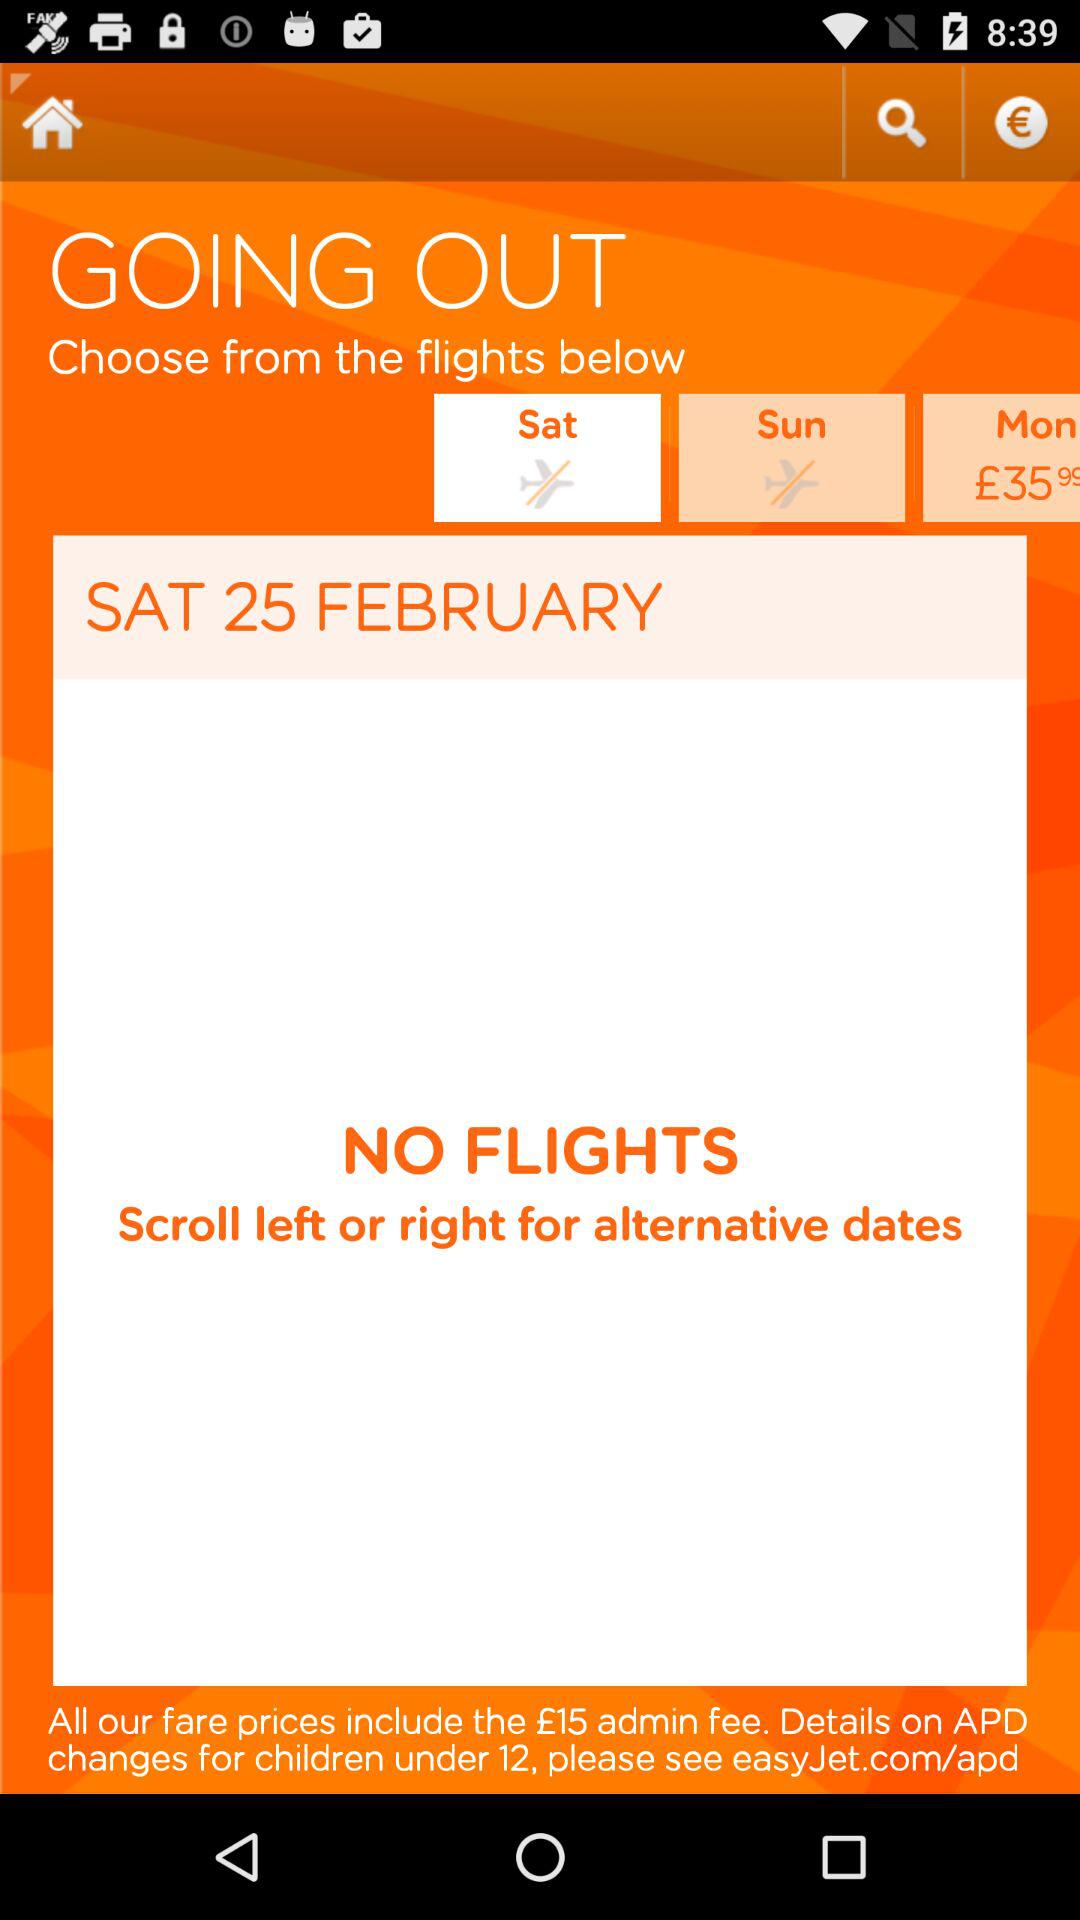How many days are available?
Answer the question using a single word or phrase. 3 